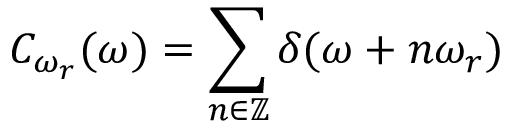Convert formula to latex. <formula><loc_0><loc_0><loc_500><loc_500>C _ { \omega _ { r } } ( \omega ) = \sum _ { n \in \mathbb { Z } } \delta ( \omega + n \omega _ { r } )</formula> 